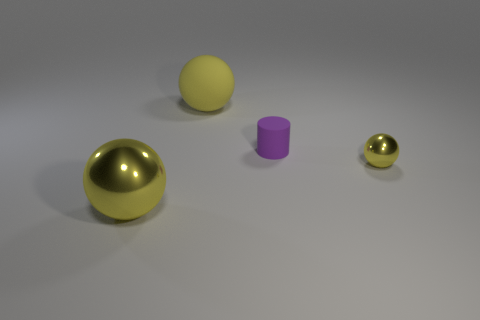How many yellow balls must be subtracted to get 1 yellow balls? 2 Add 3 small objects. How many objects exist? 7 Subtract all cylinders. How many objects are left? 3 Subtract all big yellow metal balls. Subtract all gray metal cylinders. How many objects are left? 3 Add 3 yellow rubber spheres. How many yellow rubber spheres are left? 4 Add 2 tiny matte cylinders. How many tiny matte cylinders exist? 3 Subtract 1 purple cylinders. How many objects are left? 3 